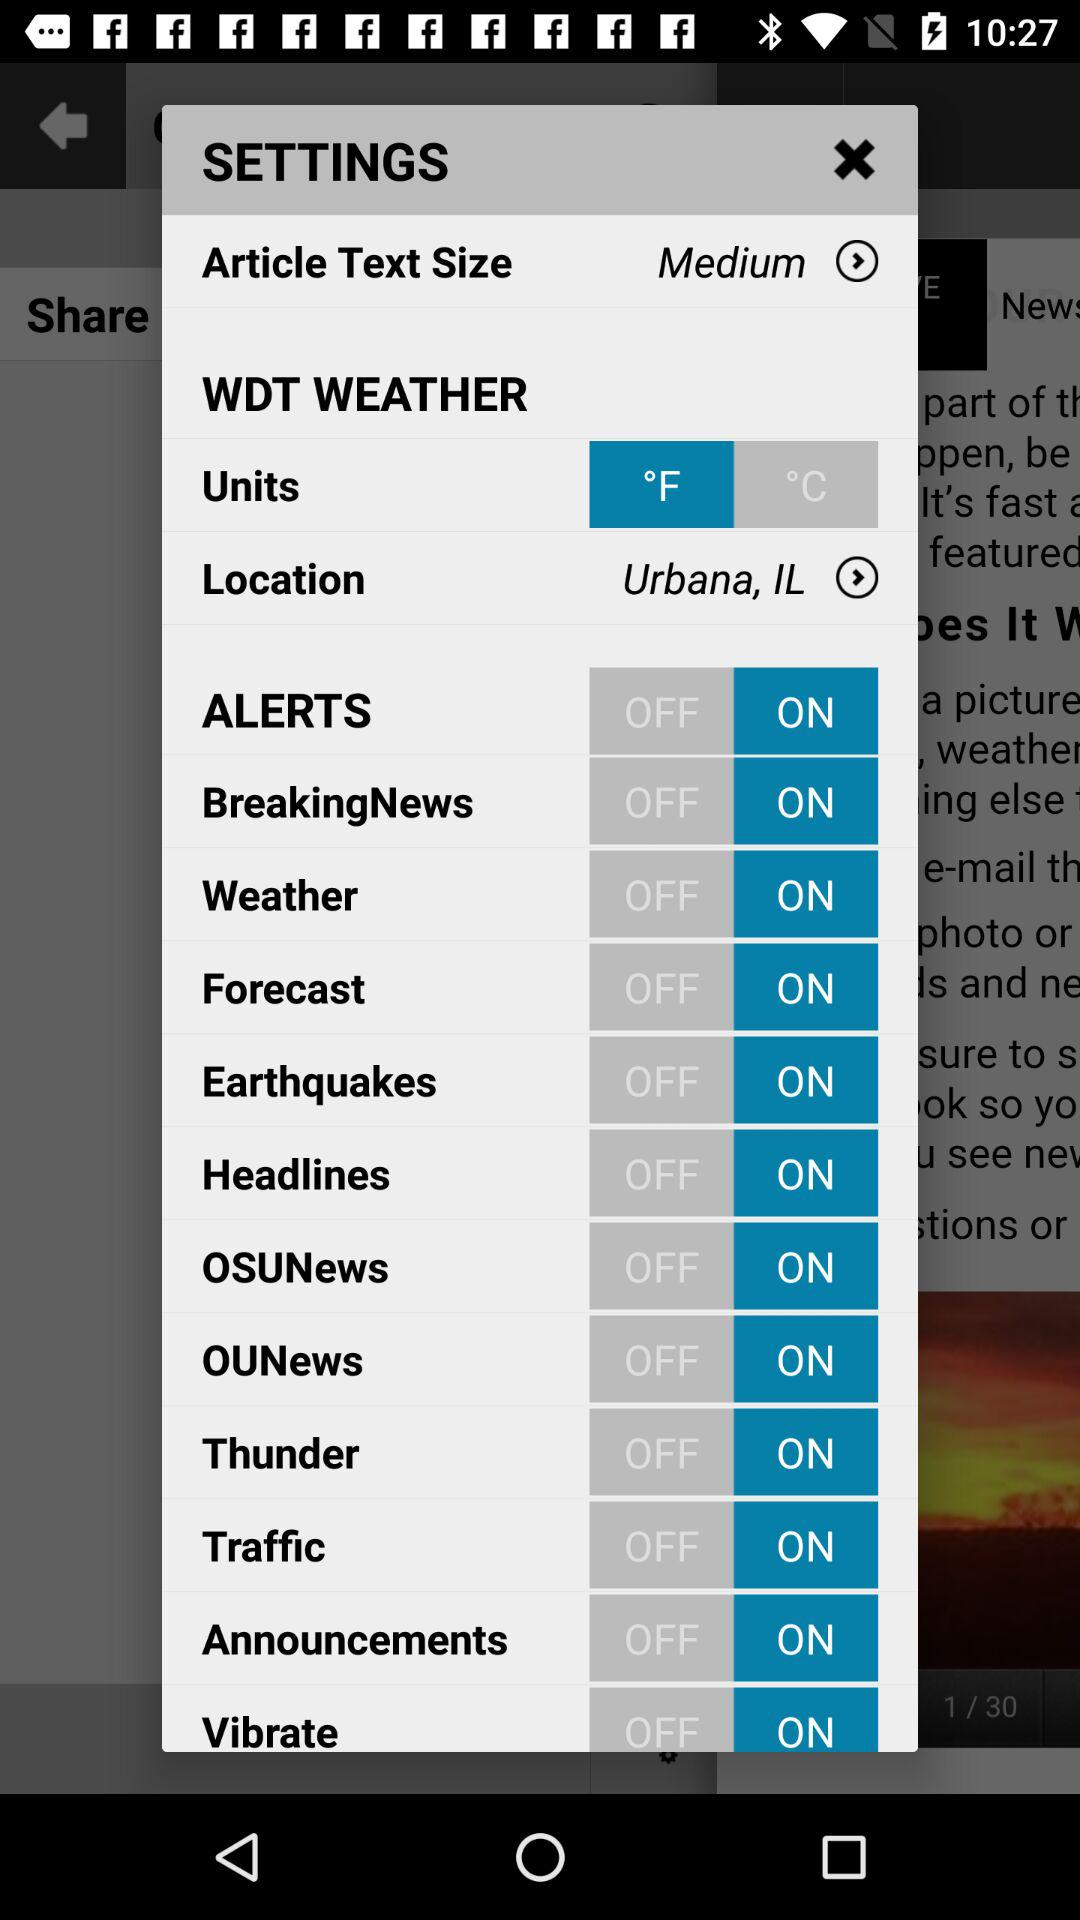What is the selected unit of weather? The selected unit of weather is °F. 